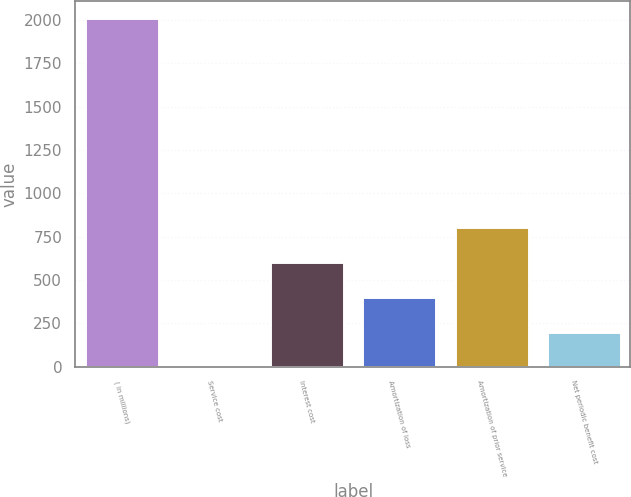<chart> <loc_0><loc_0><loc_500><loc_500><bar_chart><fcel>( in millions)<fcel>Service cost<fcel>Interest cost<fcel>Amortization of loss<fcel>Amortization of prior service<fcel>Net periodic benefit cost<nl><fcel>2010<fcel>0.9<fcel>603.63<fcel>402.72<fcel>804.54<fcel>201.81<nl></chart> 